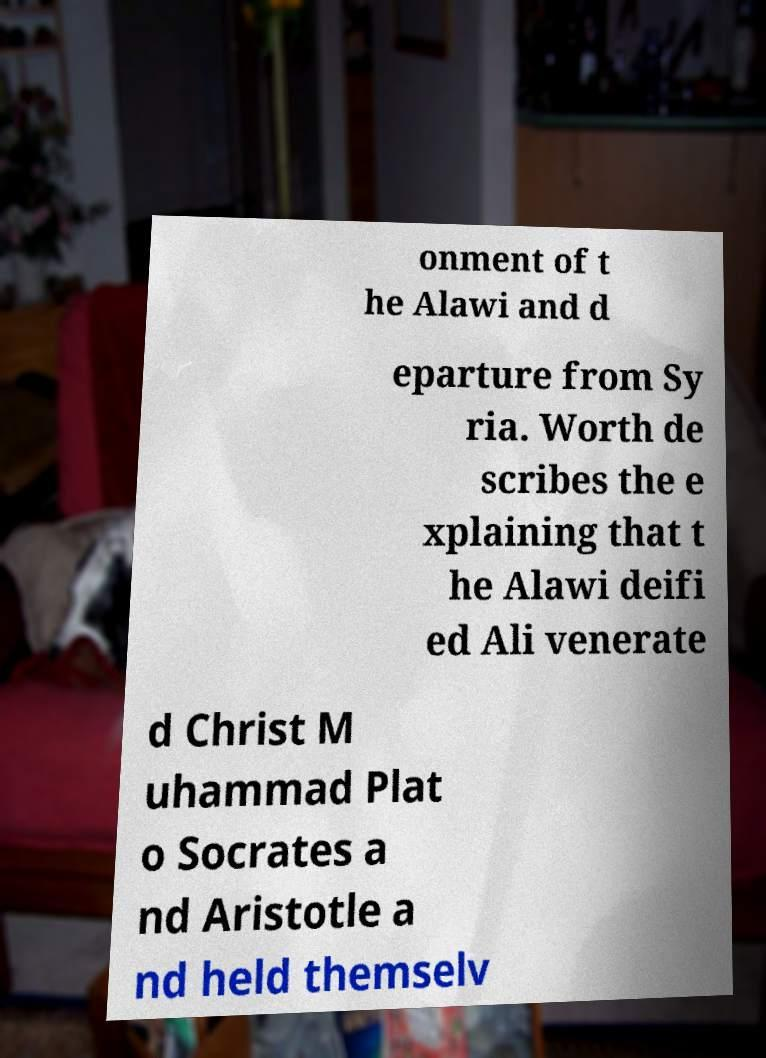Please identify and transcribe the text found in this image. onment of t he Alawi and d eparture from Sy ria. Worth de scribes the e xplaining that t he Alawi deifi ed Ali venerate d Christ M uhammad Plat o Socrates a nd Aristotle a nd held themselv 